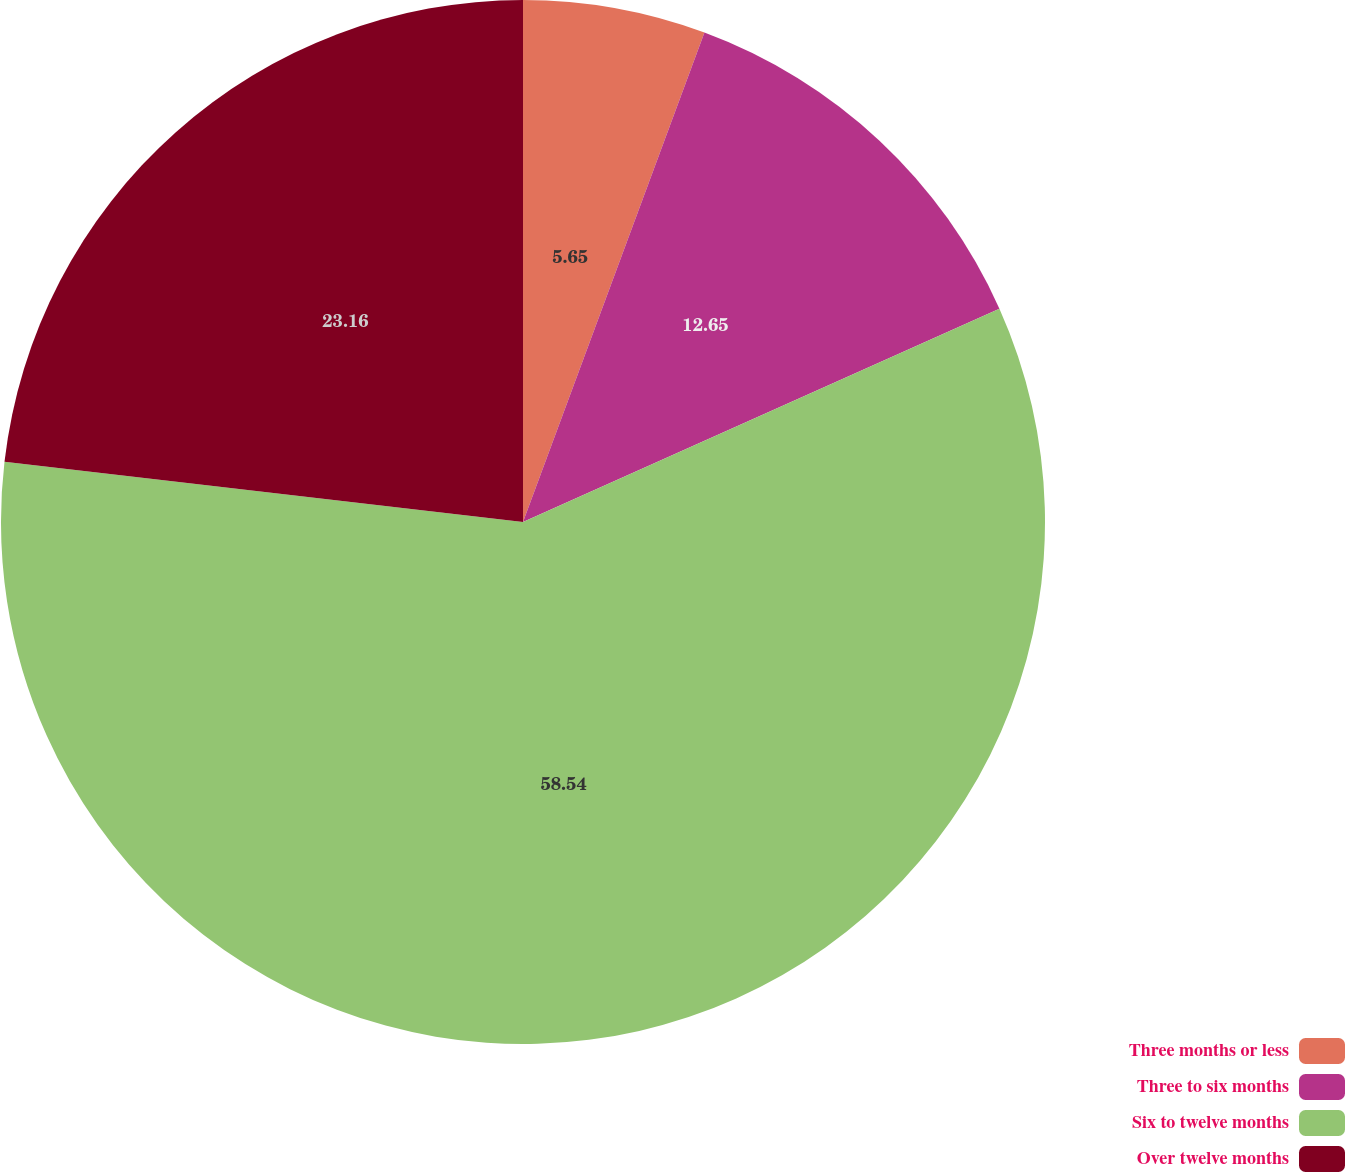Convert chart to OTSL. <chart><loc_0><loc_0><loc_500><loc_500><pie_chart><fcel>Three months or less<fcel>Three to six months<fcel>Six to twelve months<fcel>Over twelve months<nl><fcel>5.65%<fcel>12.65%<fcel>58.54%<fcel>23.16%<nl></chart> 